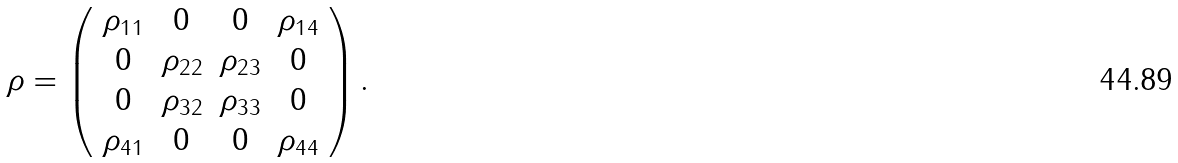Convert formula to latex. <formula><loc_0><loc_0><loc_500><loc_500>\rho = \left ( \begin{array} { c c c c } \rho _ { 1 1 } & 0 & 0 & \rho _ { 1 4 } \\ 0 & \rho _ { 2 2 } & \rho _ { 2 3 } & 0 \\ 0 & \rho _ { 3 2 } & \rho _ { 3 3 } & 0 \\ \rho _ { 4 1 } & 0 & 0 & \rho _ { 4 4 } \end{array} \right ) .</formula> 